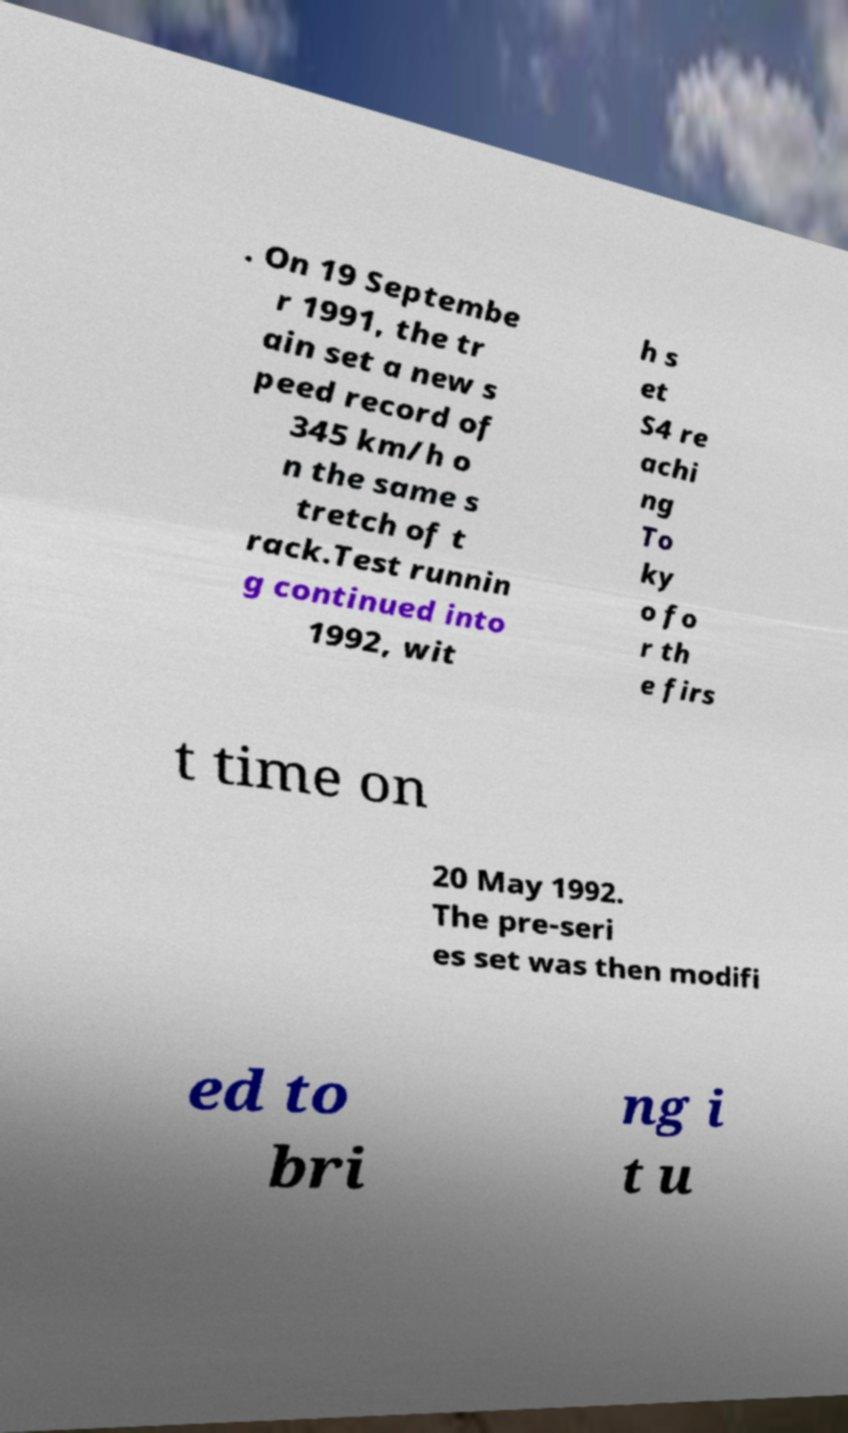I need the written content from this picture converted into text. Can you do that? . On 19 Septembe r 1991, the tr ain set a new s peed record of 345 km/h o n the same s tretch of t rack.Test runnin g continued into 1992, wit h s et S4 re achi ng To ky o fo r th e firs t time on 20 May 1992. The pre-seri es set was then modifi ed to bri ng i t u 